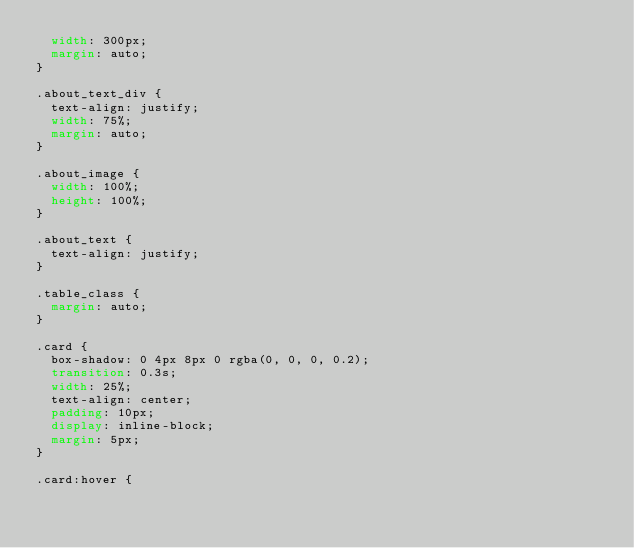Convert code to text. <code><loc_0><loc_0><loc_500><loc_500><_CSS_>  width: 300px;
  margin: auto;
}

.about_text_div {
  text-align: justify;
  width: 75%;
  margin: auto;
}

.about_image {
  width: 100%;
  height: 100%;
}

.about_text {
  text-align: justify;
}

.table_class {
  margin: auto;
}

.card {
  box-shadow: 0 4px 8px 0 rgba(0, 0, 0, 0.2);
  transition: 0.3s;
  width: 25%;
  text-align: center;
  padding: 10px;
  display: inline-block;
  margin: 5px;
}

.card:hover {</code> 